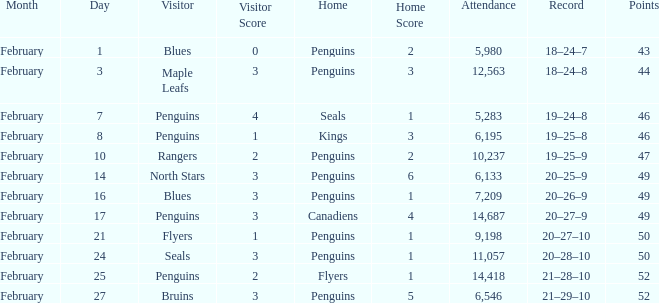What is the history of a 2-1 result? 21–28–10. 